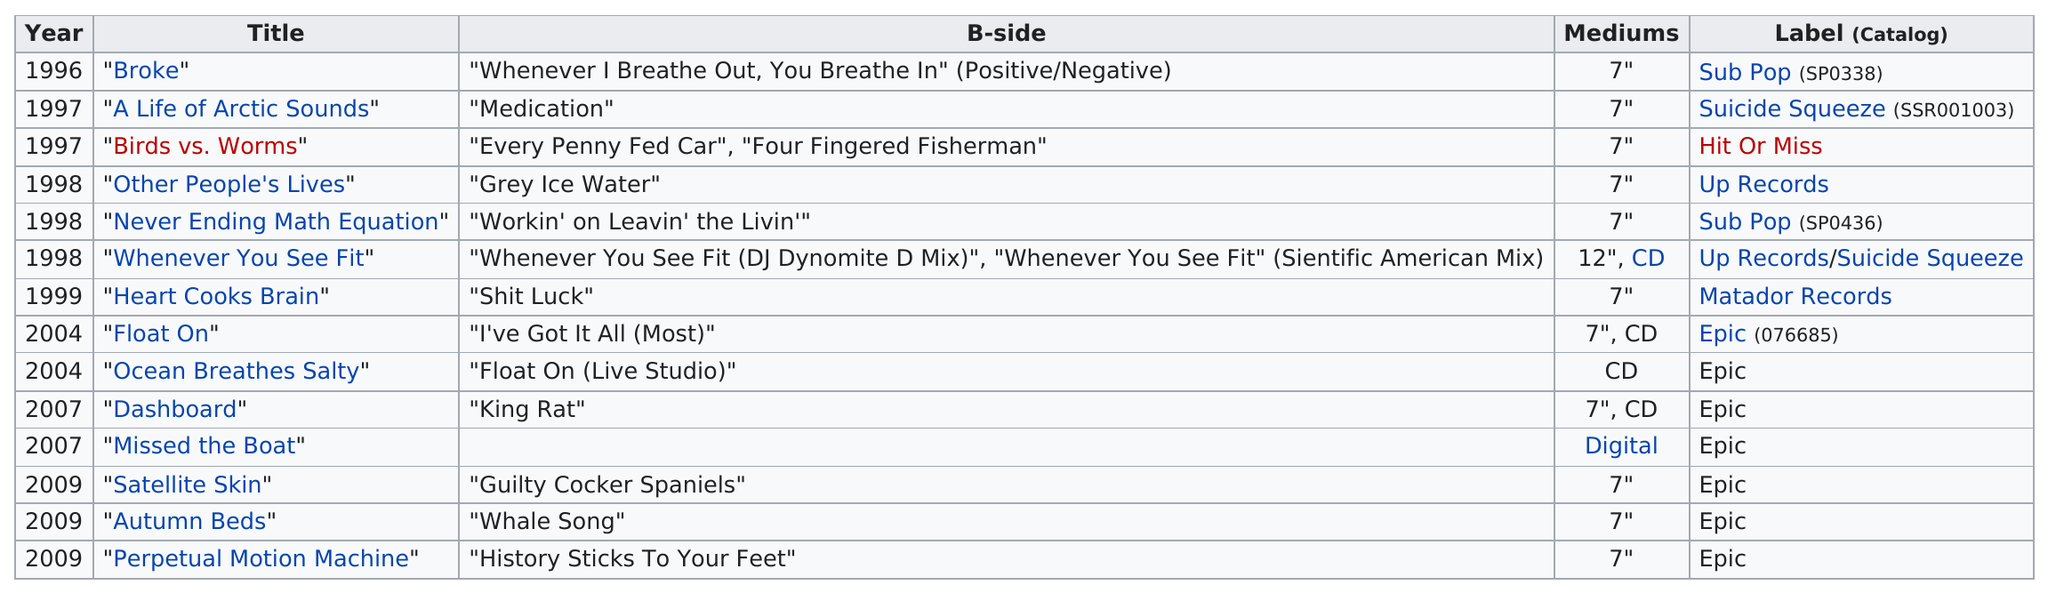Mention a couple of crucial points in this snapshot. In 2009, there were approximately 3 million unmarried individuals in the United States. The total number of singles is 14. Of the modest mouse singles that begin with the letter "b", there are two. As of 2021, the total number of singles released after 1999 is 7. The single "Birds vs. Worms" by Modest Mouse is the only release under the Hit or Miss label. 